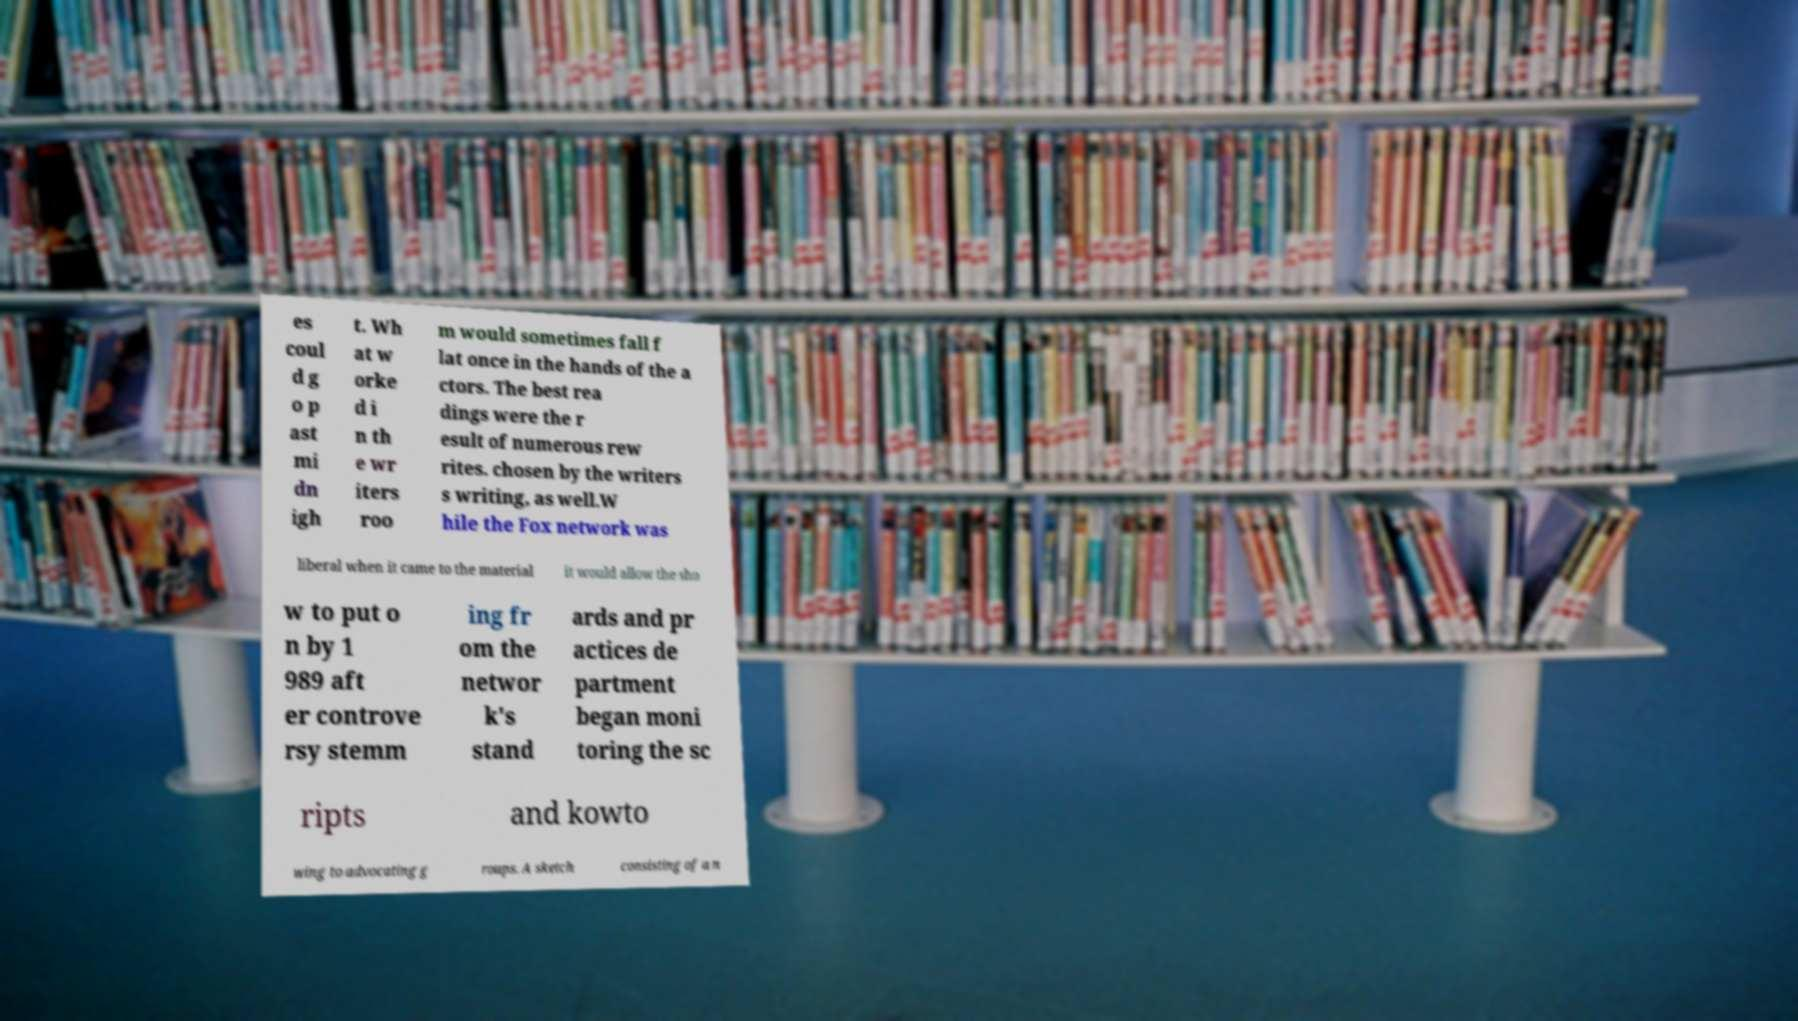Please read and relay the text visible in this image. What does it say? es coul d g o p ast mi dn igh t. Wh at w orke d i n th e wr iters roo m would sometimes fall f lat once in the hands of the a ctors. The best rea dings were the r esult of numerous rew rites. chosen by the writers s writing, as well.W hile the Fox network was liberal when it came to the material it would allow the sho w to put o n by 1 989 aft er controve rsy stemm ing fr om the networ k's stand ards and pr actices de partment began moni toring the sc ripts and kowto wing to advocating g roups. A sketch consisting of a n 